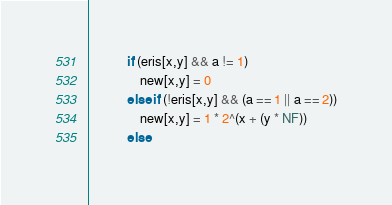Convert code to text. <code><loc_0><loc_0><loc_500><loc_500><_Awk_>            if (eris[x,y] && a != 1)
                new[x,y] = 0
            else if (!eris[x,y] && (a == 1 || a == 2))
                new[x,y] = 1 * 2^(x + (y * NF))
            else</code> 